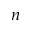<formula> <loc_0><loc_0><loc_500><loc_500>n</formula> 